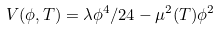<formula> <loc_0><loc_0><loc_500><loc_500>V ( \phi , T ) = \lambda \phi ^ { 4 } / 2 4 - \mu ^ { 2 } ( T ) \phi ^ { 2 }</formula> 